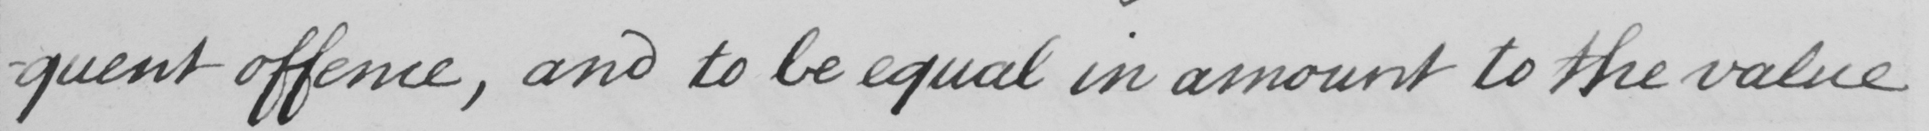Can you read and transcribe this handwriting? -quent offence , and to be equal in amount to the value 